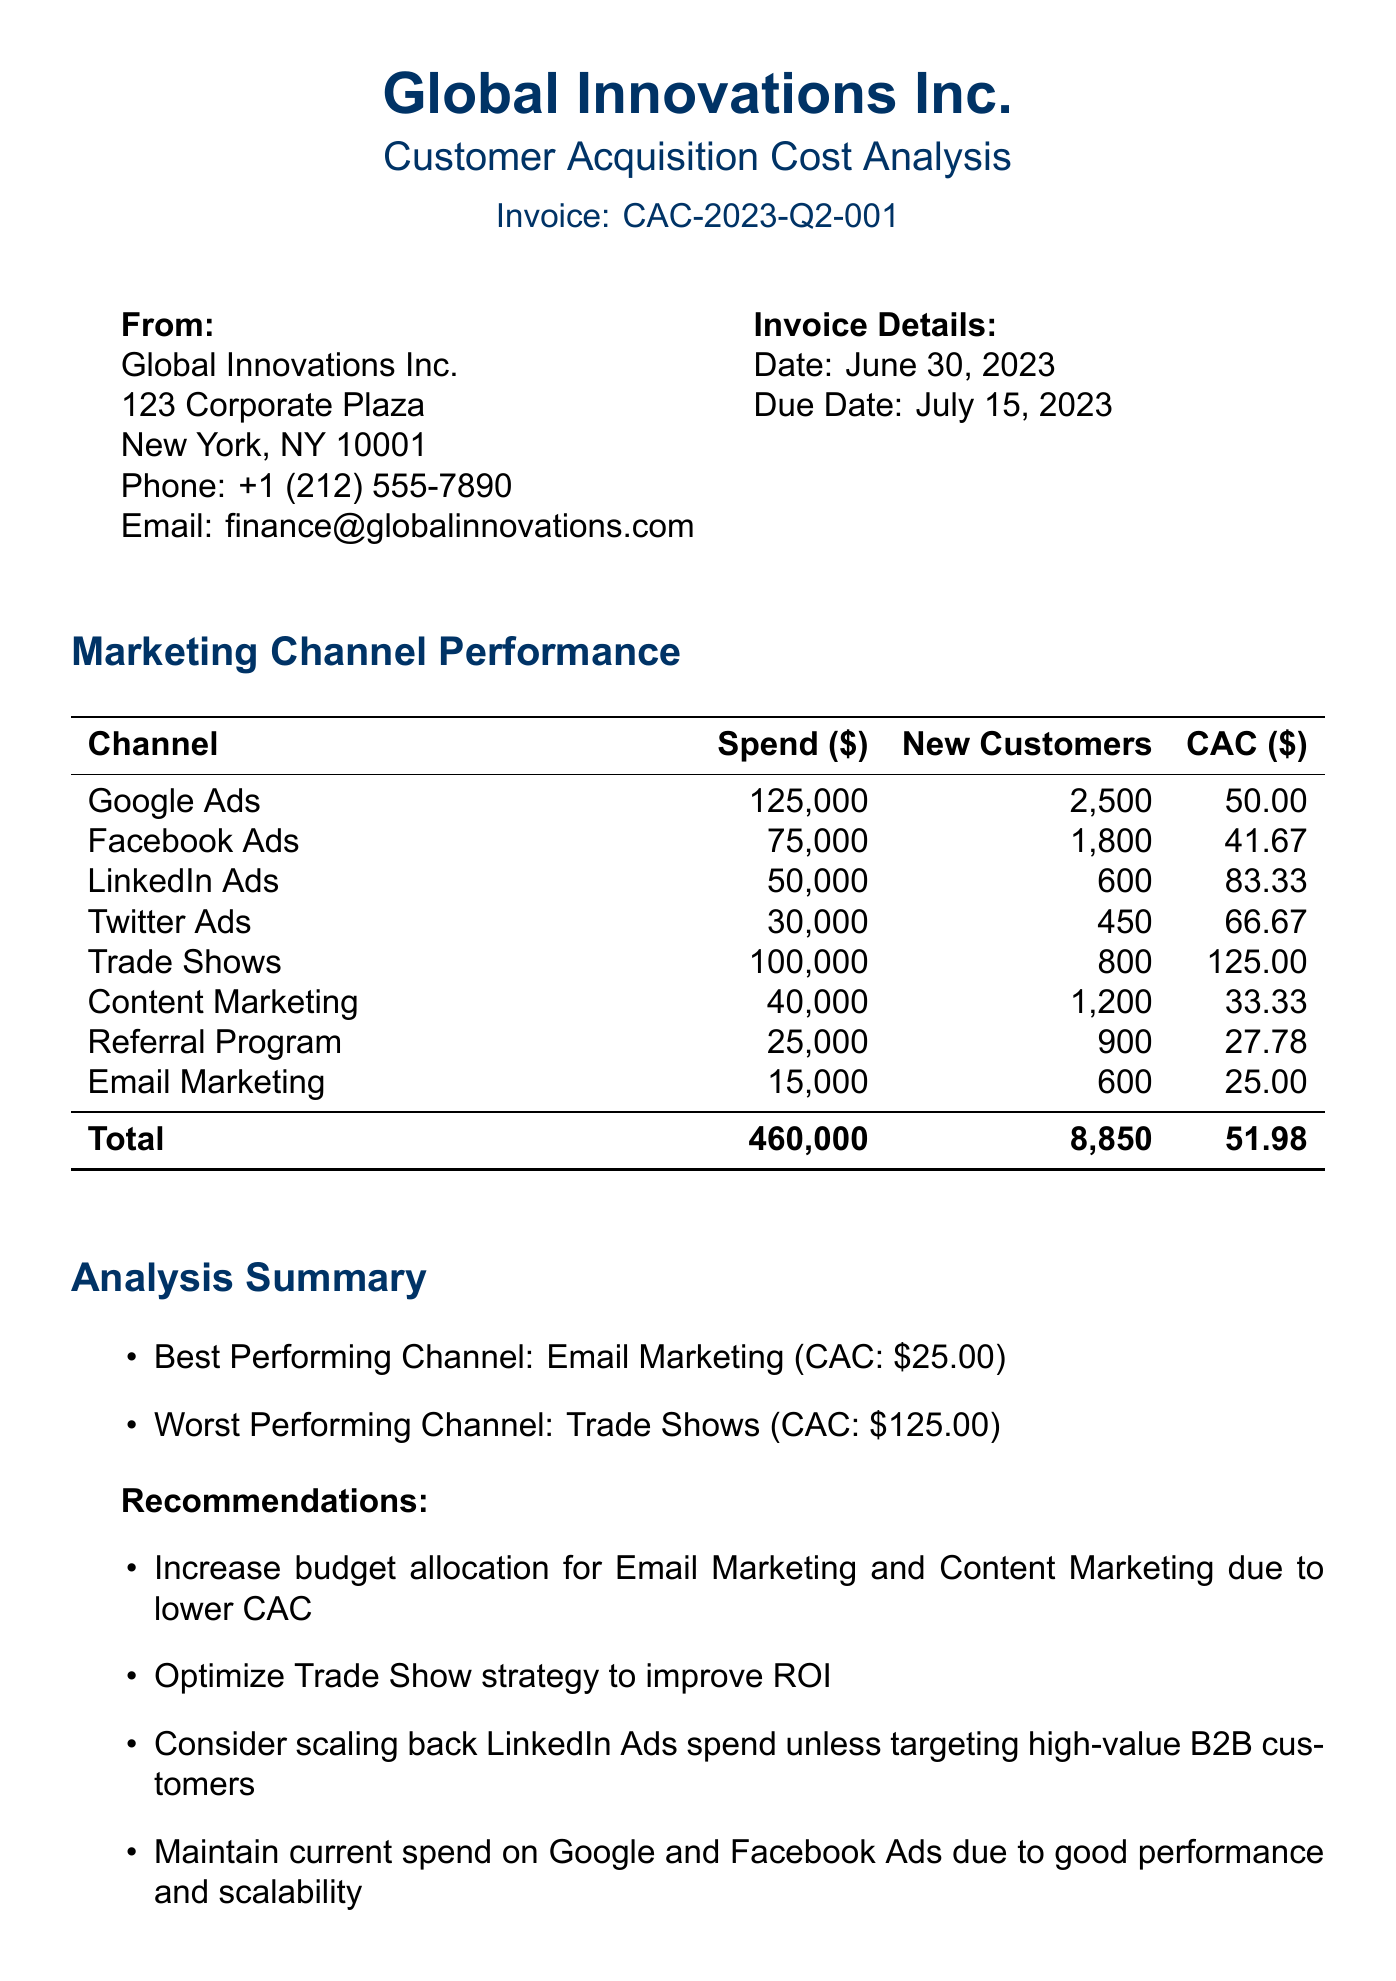what is the invoice number? The invoice number is specified in the document under invoice details, which is CAC-2023-Q2-001.
Answer: CAC-2023-Q2-001 what is the total marketing spend? The total marketing spend is the sum of all spending across channels, listed as 460,000.
Answer: 460000 who prepared the document? The document states that it was prepared by Sarah Johnson, the Marketing Analytics Manager.
Answer: Sarah Johnson which channel had the highest customer acquisition cost? The channel with the highest customer acquisition cost is Trade Shows, which has a CAC of 125.
Answer: Trade Shows how many new customers were acquired through Email Marketing? The document lists that Email Marketing acquired 600 new customers.
Answer: 600 what is the recommended action for Trade Shows? The recommendation for Trade Shows is to optimize the strategy to improve ROI.
Answer: Optimize Trade Show strategy how many new customers were acquired in total? The document indicates that a total of 8,850 new customers were acquired.
Answer: 8850 what is the customer lifetime value? The customer lifetime value is given as 500 in the key performance indicators section.
Answer: 500 what is the worst performing channel based on CAC? According to the analysis summary, the worst performing channel is Trade Shows.
Answer: Trade Shows what is the due date for the invoice? The due date specified in the invoice details is July 15, 2023.
Answer: July 15, 2023 